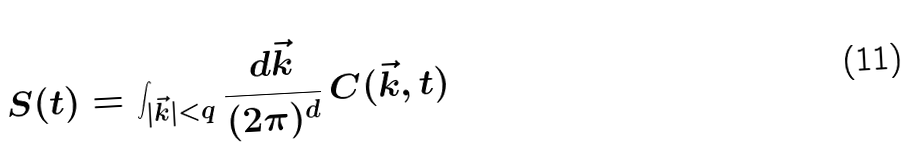Convert formula to latex. <formula><loc_0><loc_0><loc_500><loc_500>S ( t ) = \int _ { | \vec { k } | < q } \frac { d \vec { k } } { ( 2 \pi ) ^ { d } } \, C ( \vec { k } , t )</formula> 